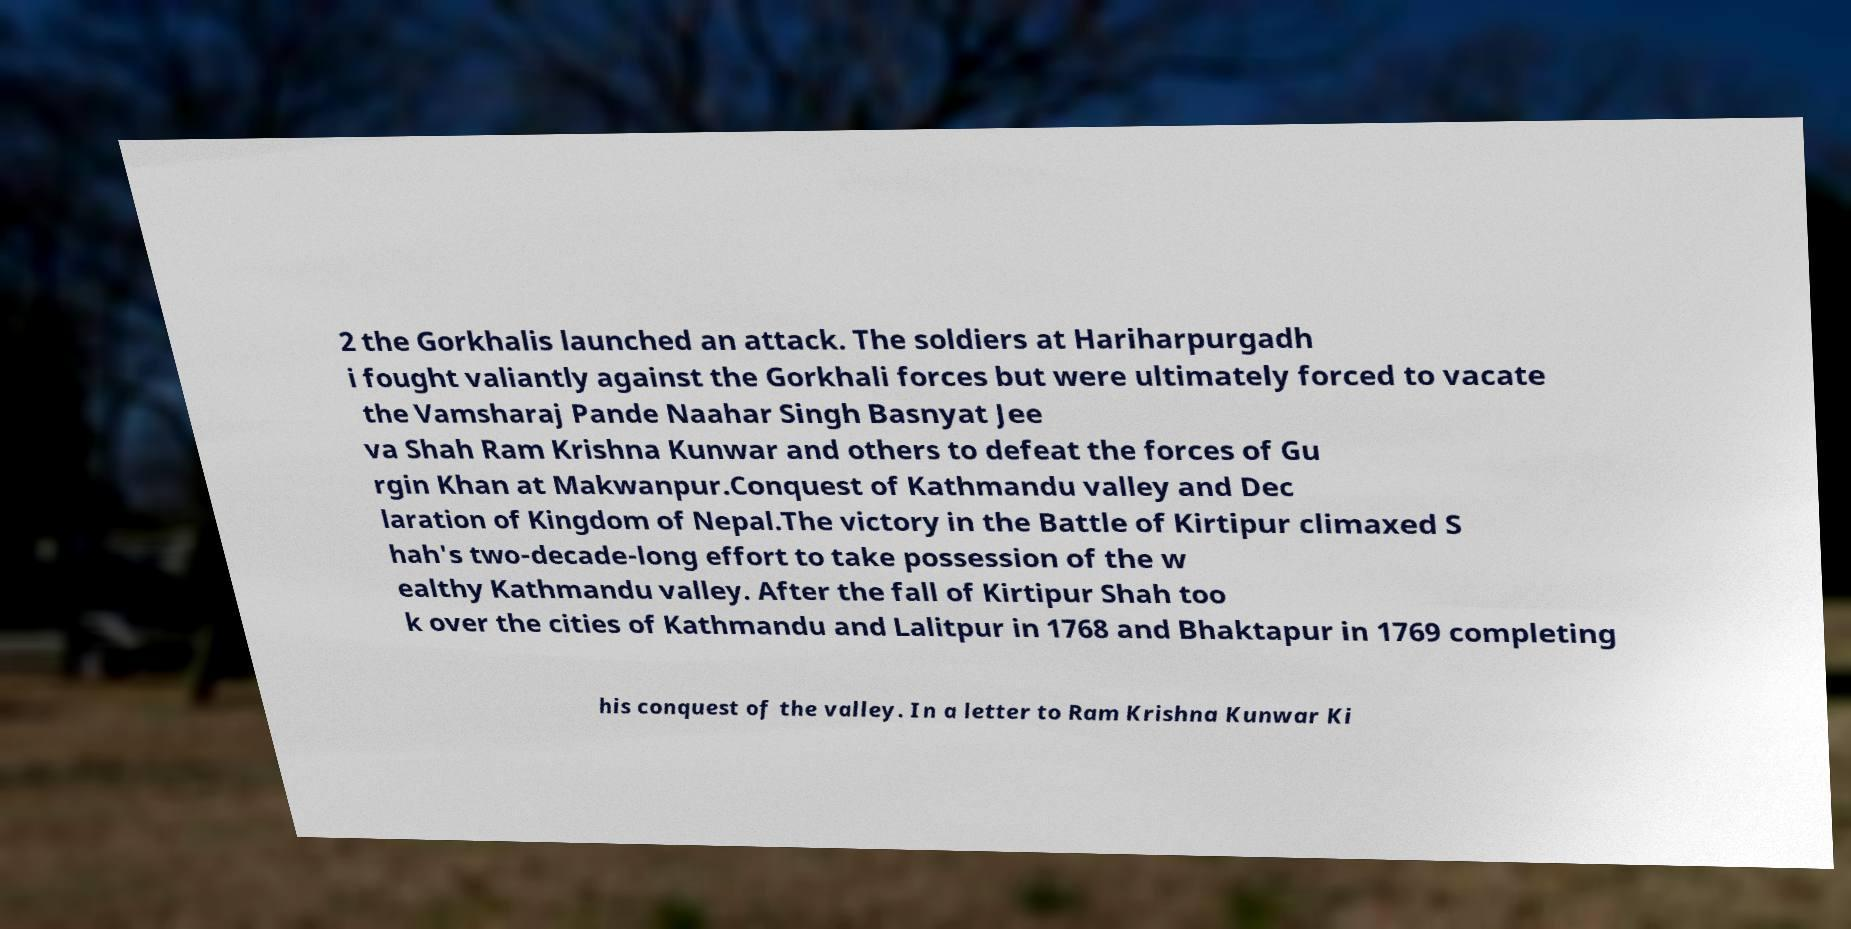Can you accurately transcribe the text from the provided image for me? 2 the Gorkhalis launched an attack. The soldiers at Hariharpurgadh i fought valiantly against the Gorkhali forces but were ultimately forced to vacate the Vamsharaj Pande Naahar Singh Basnyat Jee va Shah Ram Krishna Kunwar and others to defeat the forces of Gu rgin Khan at Makwanpur.Conquest of Kathmandu valley and Dec laration of Kingdom of Nepal.The victory in the Battle of Kirtipur climaxed S hah's two-decade-long effort to take possession of the w ealthy Kathmandu valley. After the fall of Kirtipur Shah too k over the cities of Kathmandu and Lalitpur in 1768 and Bhaktapur in 1769 completing his conquest of the valley. In a letter to Ram Krishna Kunwar Ki 